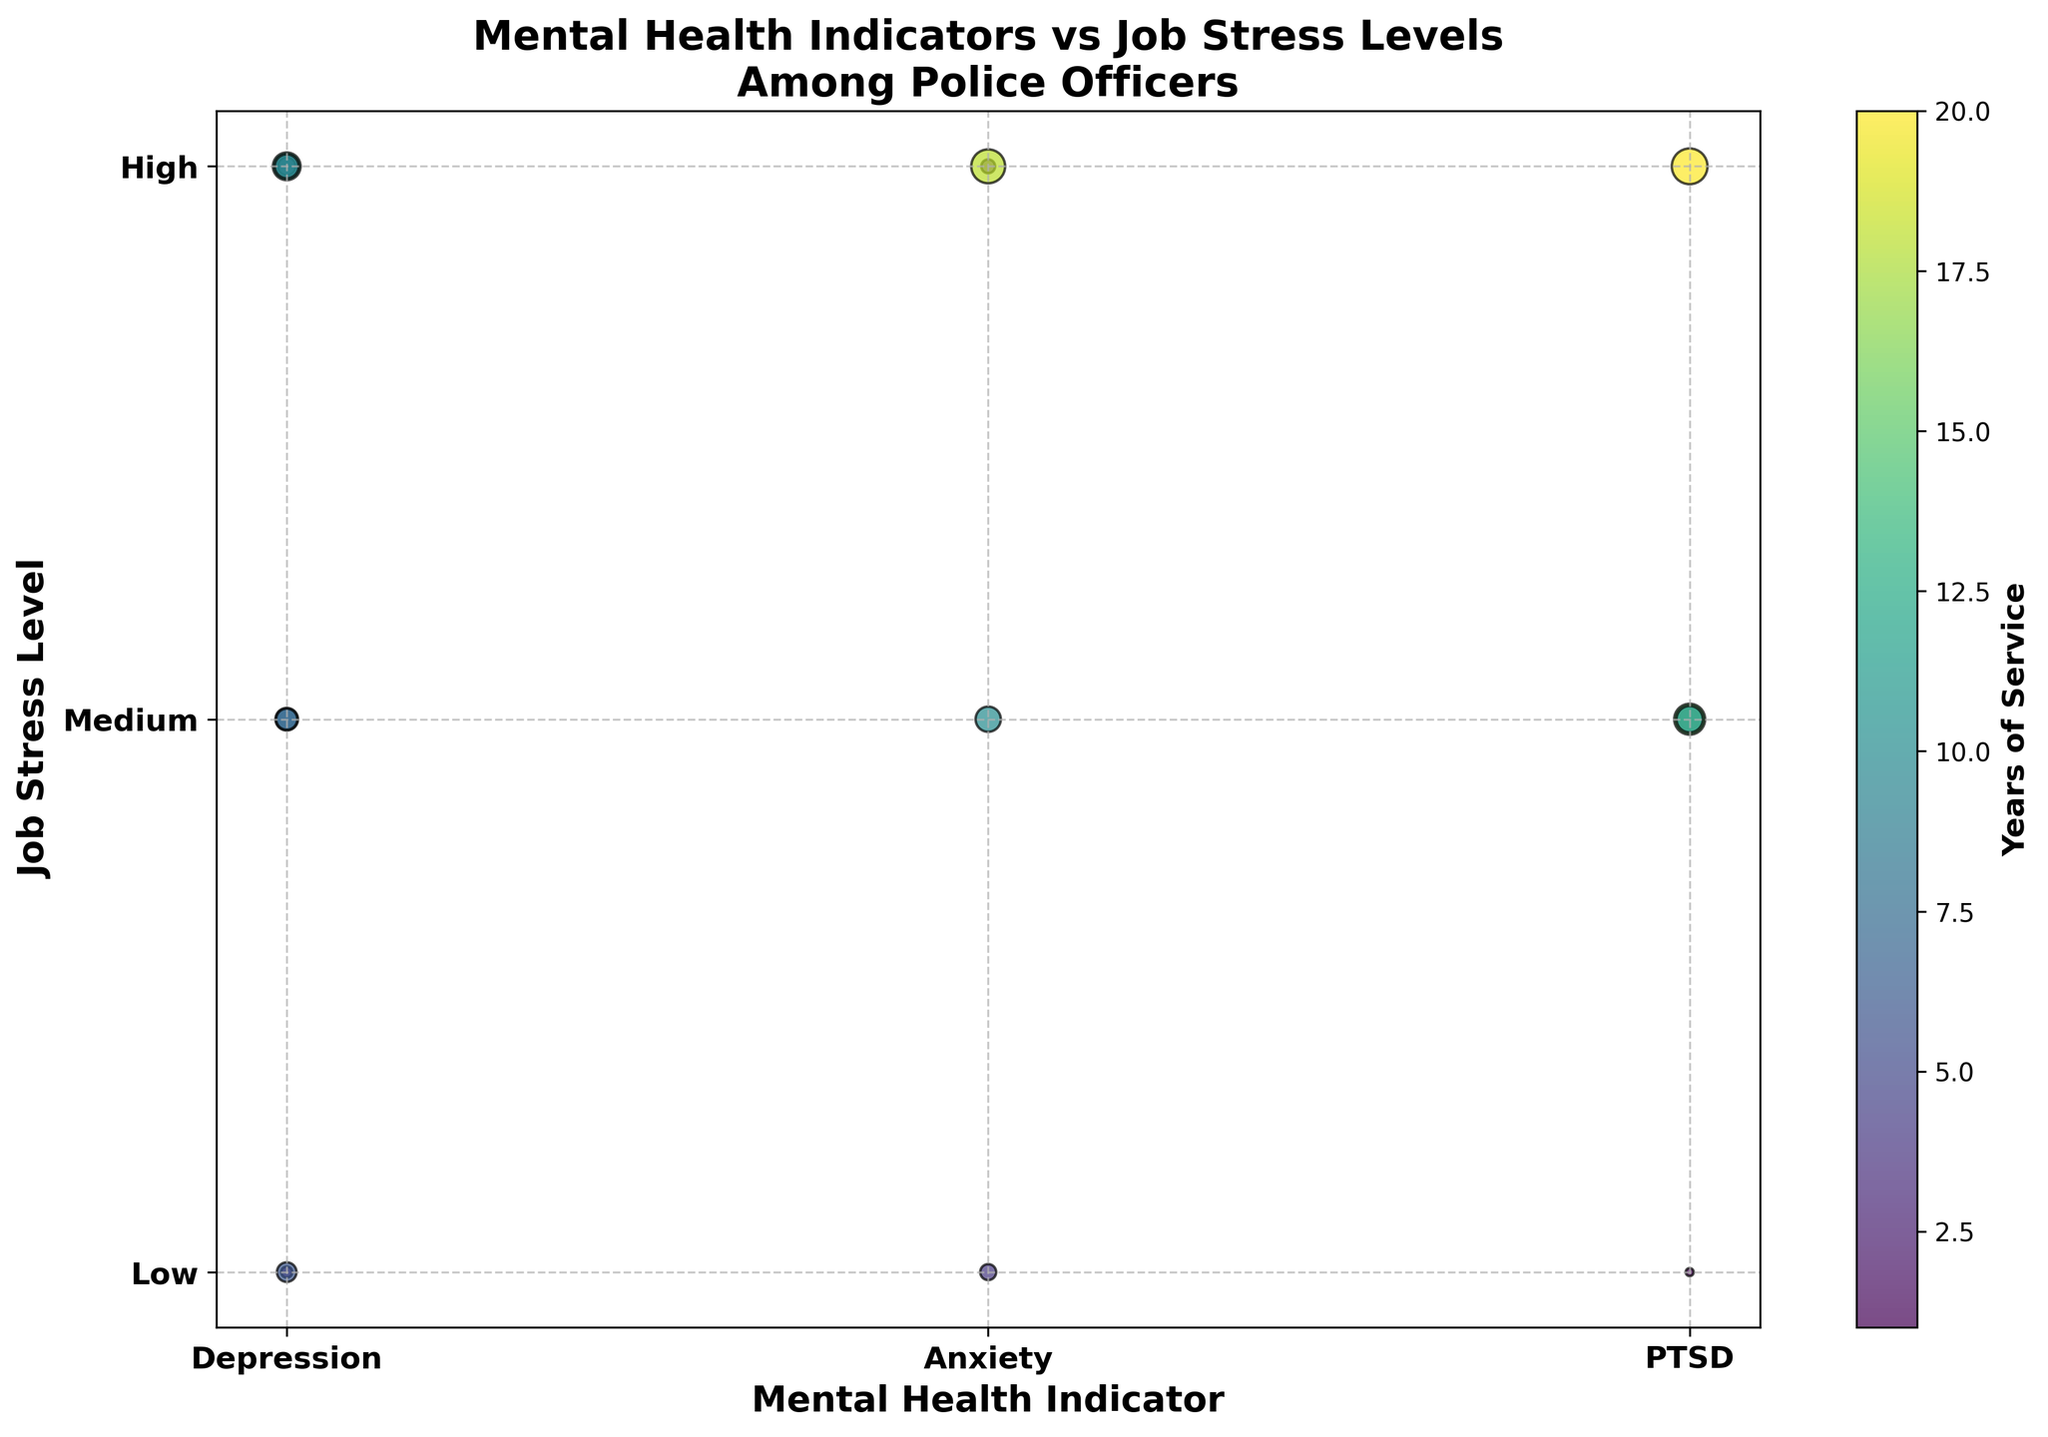How many officers in the data set have a mental health indicator of 'Depression'? We can count the number of points along the x-axis labeled 'Depression'. There are multiple points scattered along the 'Depression' category.
Answer: 6 What is the job stress level of the officer with the highest years of service? By looking at the color intensity in the legend, the darkest dot represents the highest years of service. This dot is on 'PTSD' and 'High' which indicates high job stress.
Answer: High Which mental health indicator has the most officers with 'Low' job stress level? Observing the 'Low' row on the y-axis, count how many points fall in each mental health category. 'Depression' has the most points in the 'Low' row.
Answer: Depression On average, do officers with 'Depression' have higher or lower job stress levels compared to those with 'Anxiety'? For 'Depression', visually assess the average position of points on the y-axis (mostly 'High' and 'Medium'). For 'Anxiety', points are spread more between 'High' and 'Medium'. The average looks lower for 'Anxiety'.
Answer: Lower What is the median job stress level for officers with more than 10 years of service? We need to look for officers with over 10 years (larger dots associated with darker shades). For 'High' and 'Medium' stress levels, the median would be 'High' as more data points fall in the higher range.
Answer: High 